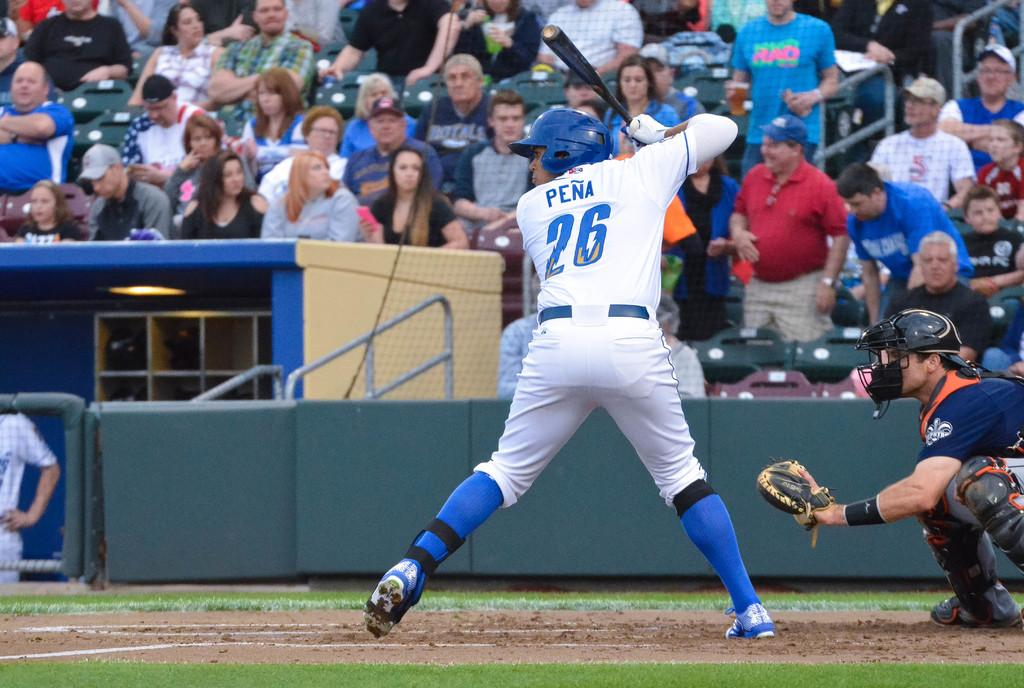<image>
Write a terse but informative summary of the picture. Pena, the baseball player, was about to hit the ball. 